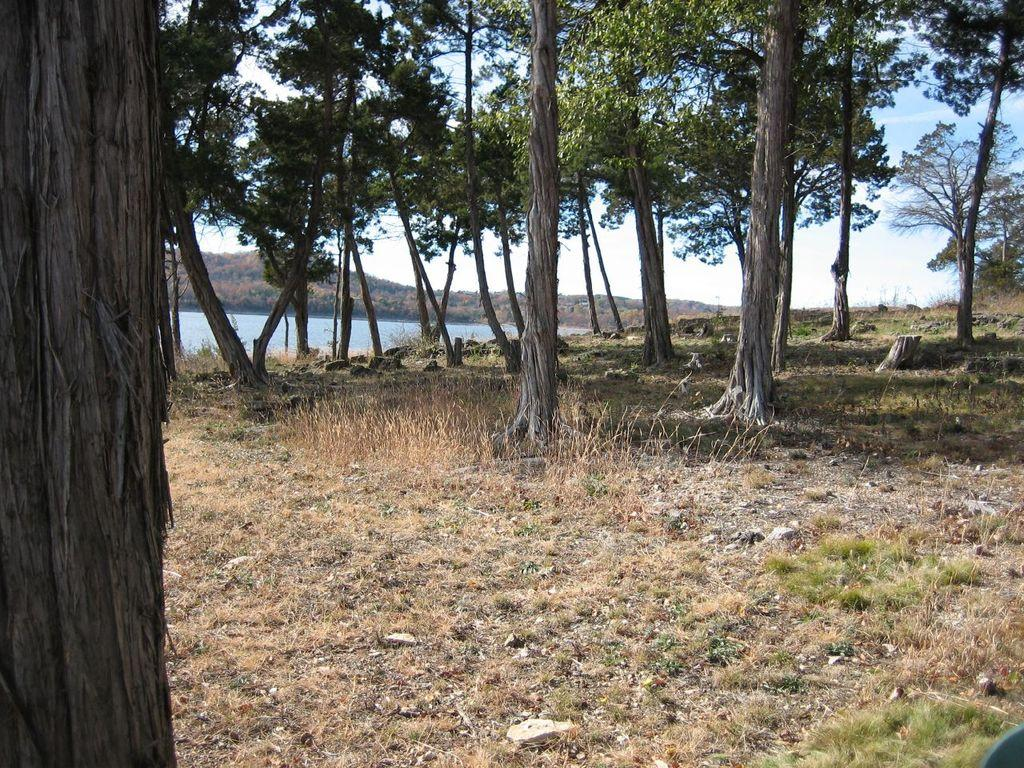What type of vegetation can be seen in the image? There are trees in the image. What natural element is visible in the image? There is water visible in the image. What type of landscape feature can be seen in the background of the image? There are mountains in the background of the image. What type of pie is being served to the babies in the image? There are no pies or babies present in the image; it features trees, water, and mountains. 